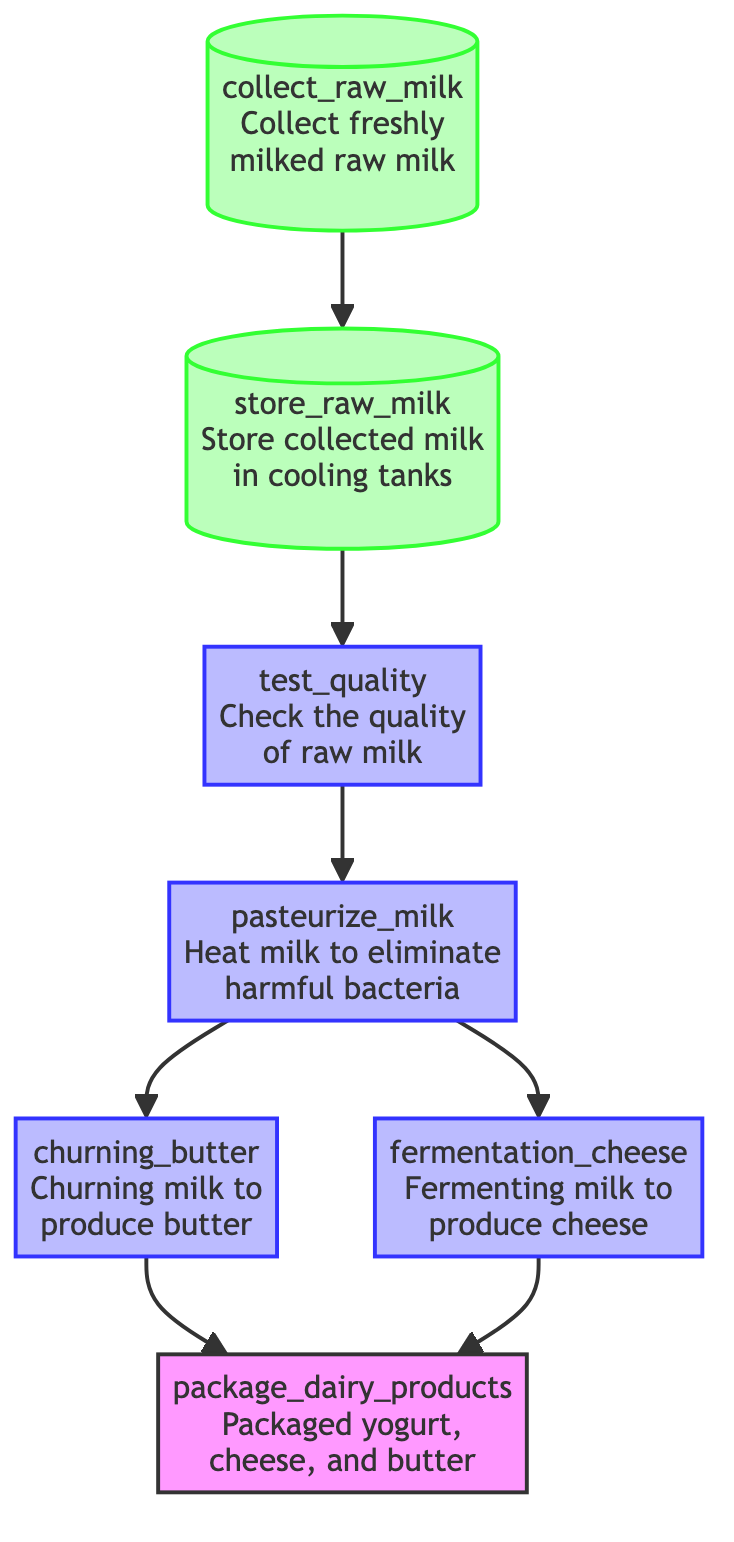What is the first step in the process? The diagram shows the first step as "collect_raw_milk," which is the action of collecting freshly milked raw milk.
Answer: collect_raw_milk How many main processing steps are involved in the diagram? The main processing steps after raw milk collection are "test_quality," "pasteurize_milk," "churning_butter," and "fermentation_cheese," amounting to four significant steps.
Answer: four Which step follows the quality testing of raw milk? After the "test_quality" step, the next action is "pasteurize_milk," which involves heating the milk to eliminate harmful bacteria.
Answer: pasteurize_milk What products are packaged at the end of the process? The final output step is "package_dairy_products," where yogurt, cheese, and butter are packaged.
Answer: Packaged yogurt, cheese, and butter How is milk prepared for cheese production? The milk is subjected to "fermentation_cheese," which involves fermenting the milk to produce cheese after it has been pasteurized.
Answer: fermentation_cheese Which nodes are classified as storage in the diagram? The nodes "collect_raw_milk" and "store_raw_milk" are designated as storage, indicating they deal with holding raw milk before processing.
Answer: collect_raw_milk, store_raw_milk What happens to milk after it is pasteurized? Following pasteurization, the milk can go into two different paths: it can either be turned into butter through "churning_butter" or into cheese through "fermentation_cheese."
Answer: churning_butter, fermentation_cheese Can cheese and butter be produced simultaneously? Yes, since the diagram shows that after pasteurization, milk can be processed into cheese and butter separately, making it possible for both to be produced at the same time.
Answer: Yes 